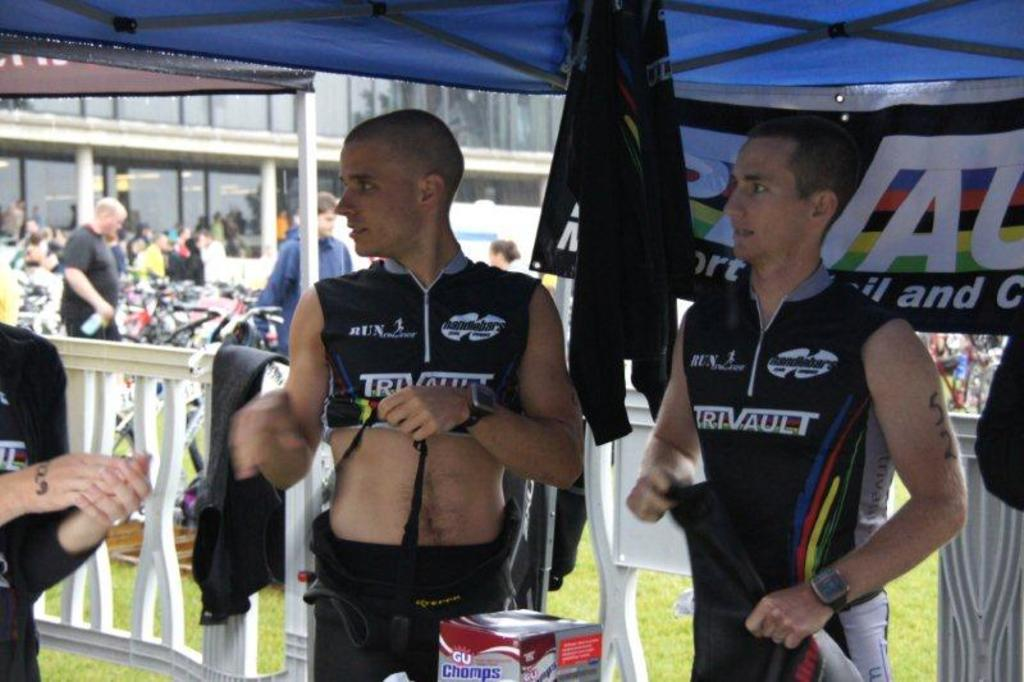<image>
Share a concise interpretation of the image provided. a boy standing with the word trivault on his outfit 